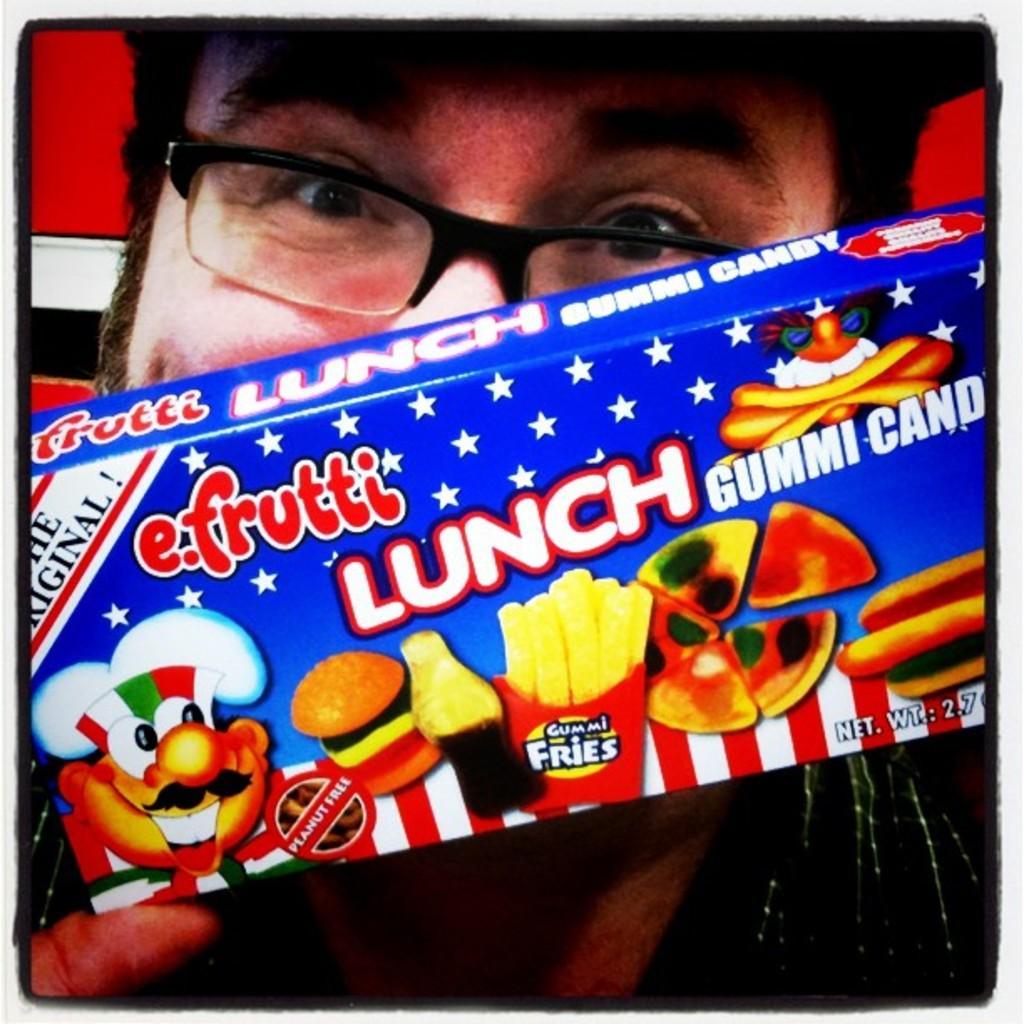Please provide a concise description of this image. In the image I can see a person who is wearing the spectacles and holding the box. 